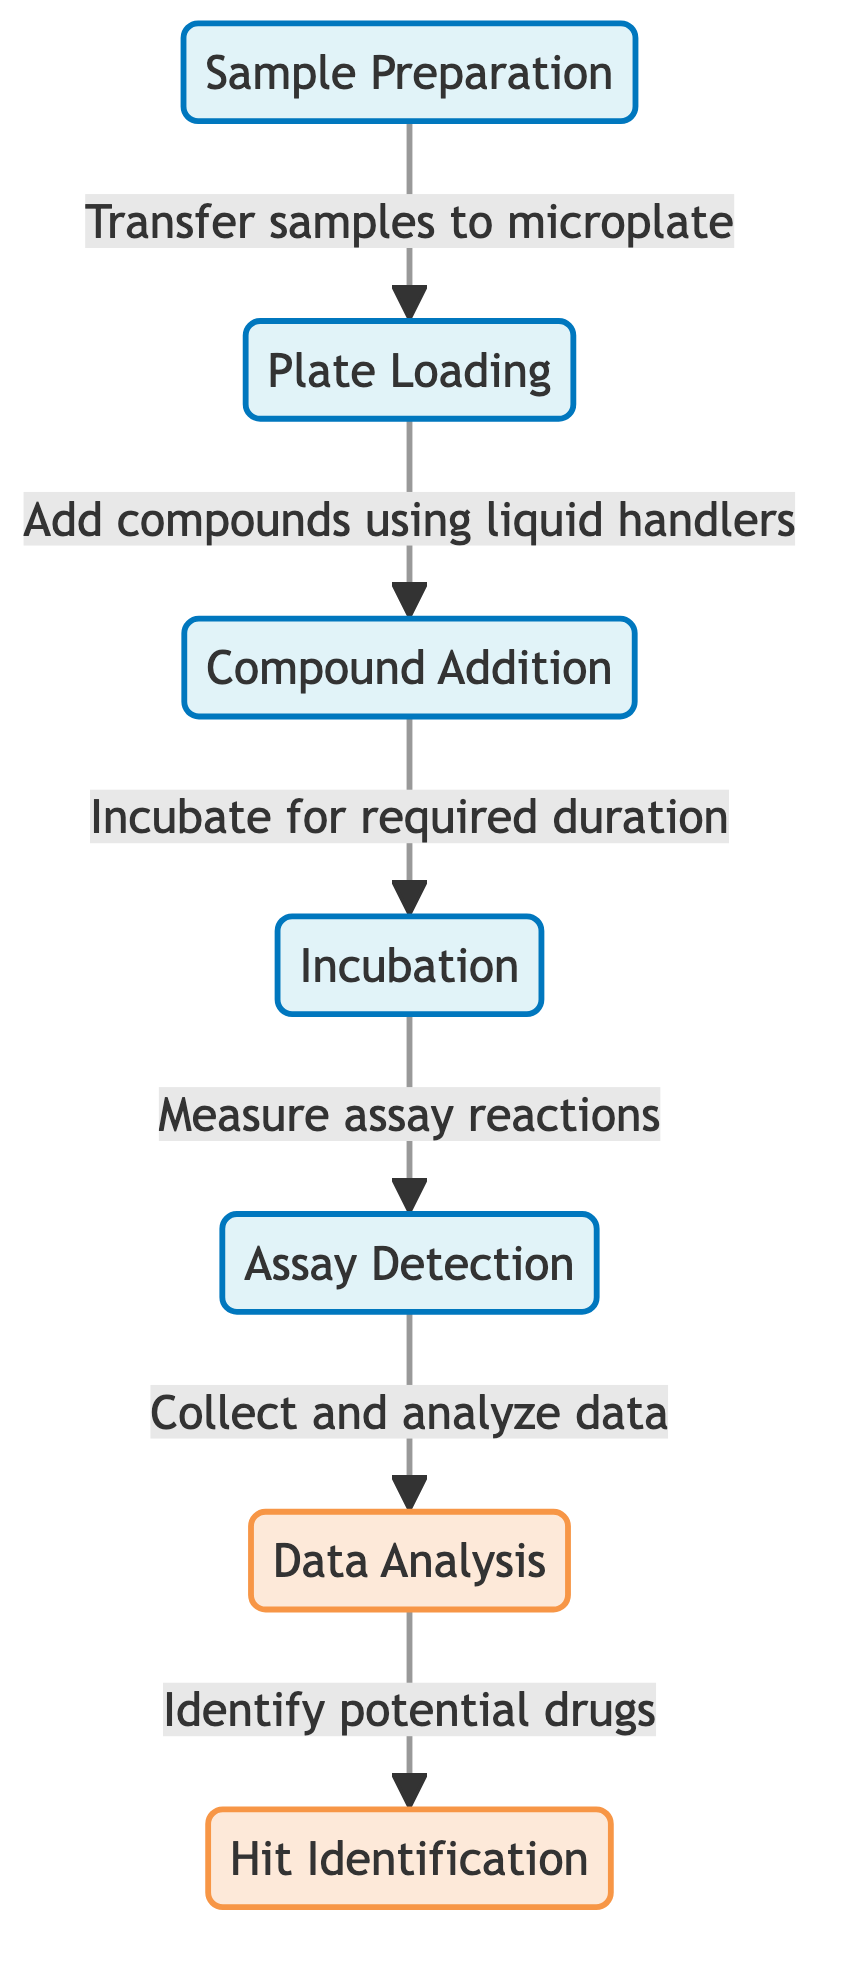What is the first step in the workflow? The first node in the diagram is "Sample Preparation," indicating that it is the initial stage of the experimental workflow.
Answer: Sample Preparation How many stages are there in the workflow? The workflow includes six distinct stages or nodes: Sample Preparation, Plate Loading, Compound Addition, Incubation, Assay Detection, and Data Analysis.
Answer: Six Which stage follows "Plate Loading"? According to the directional flow of the diagram, "Compound Addition" directly follows "Plate Loading."
Answer: Compound Addition What type of analysis occurs after "Data Analysis"? The diagram indicates that "Hit Identification" is the next step that comes after "Data Analysis."
Answer: Hit Identification What action occurs before "Incubation"? The arrow from "Compound Addition" to "Incubation" shows that the addition of compounds occurs before the incubation process begins.
Answer: Compound Addition What do you do after measuring assay reactions? The diagram specifies that after measuring assay reactions in the "Assay Detection" stage, the next action is to "Collect and analyze data."
Answer: Collect and analyze data How many analysis steps are indicated in the workflow? There are two analysis-specific stages mentioned in the workflow: "Data Analysis" and "Hit Identification."
Answer: Two What is the role of the "Assay Detection" stage? The diagram indicates that the role of the "Assay Detection" stage is to measure assay reactions, allowing for subsequent data collection and analysis.
Answer: Measure assay reactions What is the relationship between "Incubation" and "Assay Detection"? "Incubation" is linked to "Assay Detection" as the former must be completed before measuring assay reactions can occur.
Answer: Incubation precedes Assay Detection 